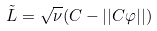<formula> <loc_0><loc_0><loc_500><loc_500>\tilde { L } = \sqrt { \nu } ( C - | | C \varphi | | )</formula> 